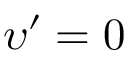Convert formula to latex. <formula><loc_0><loc_0><loc_500><loc_500>\upsilon ^ { \prime } = 0</formula> 